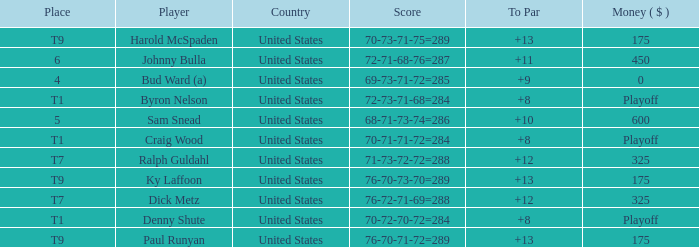What was the total To Par for Craig Wood? 8.0. 